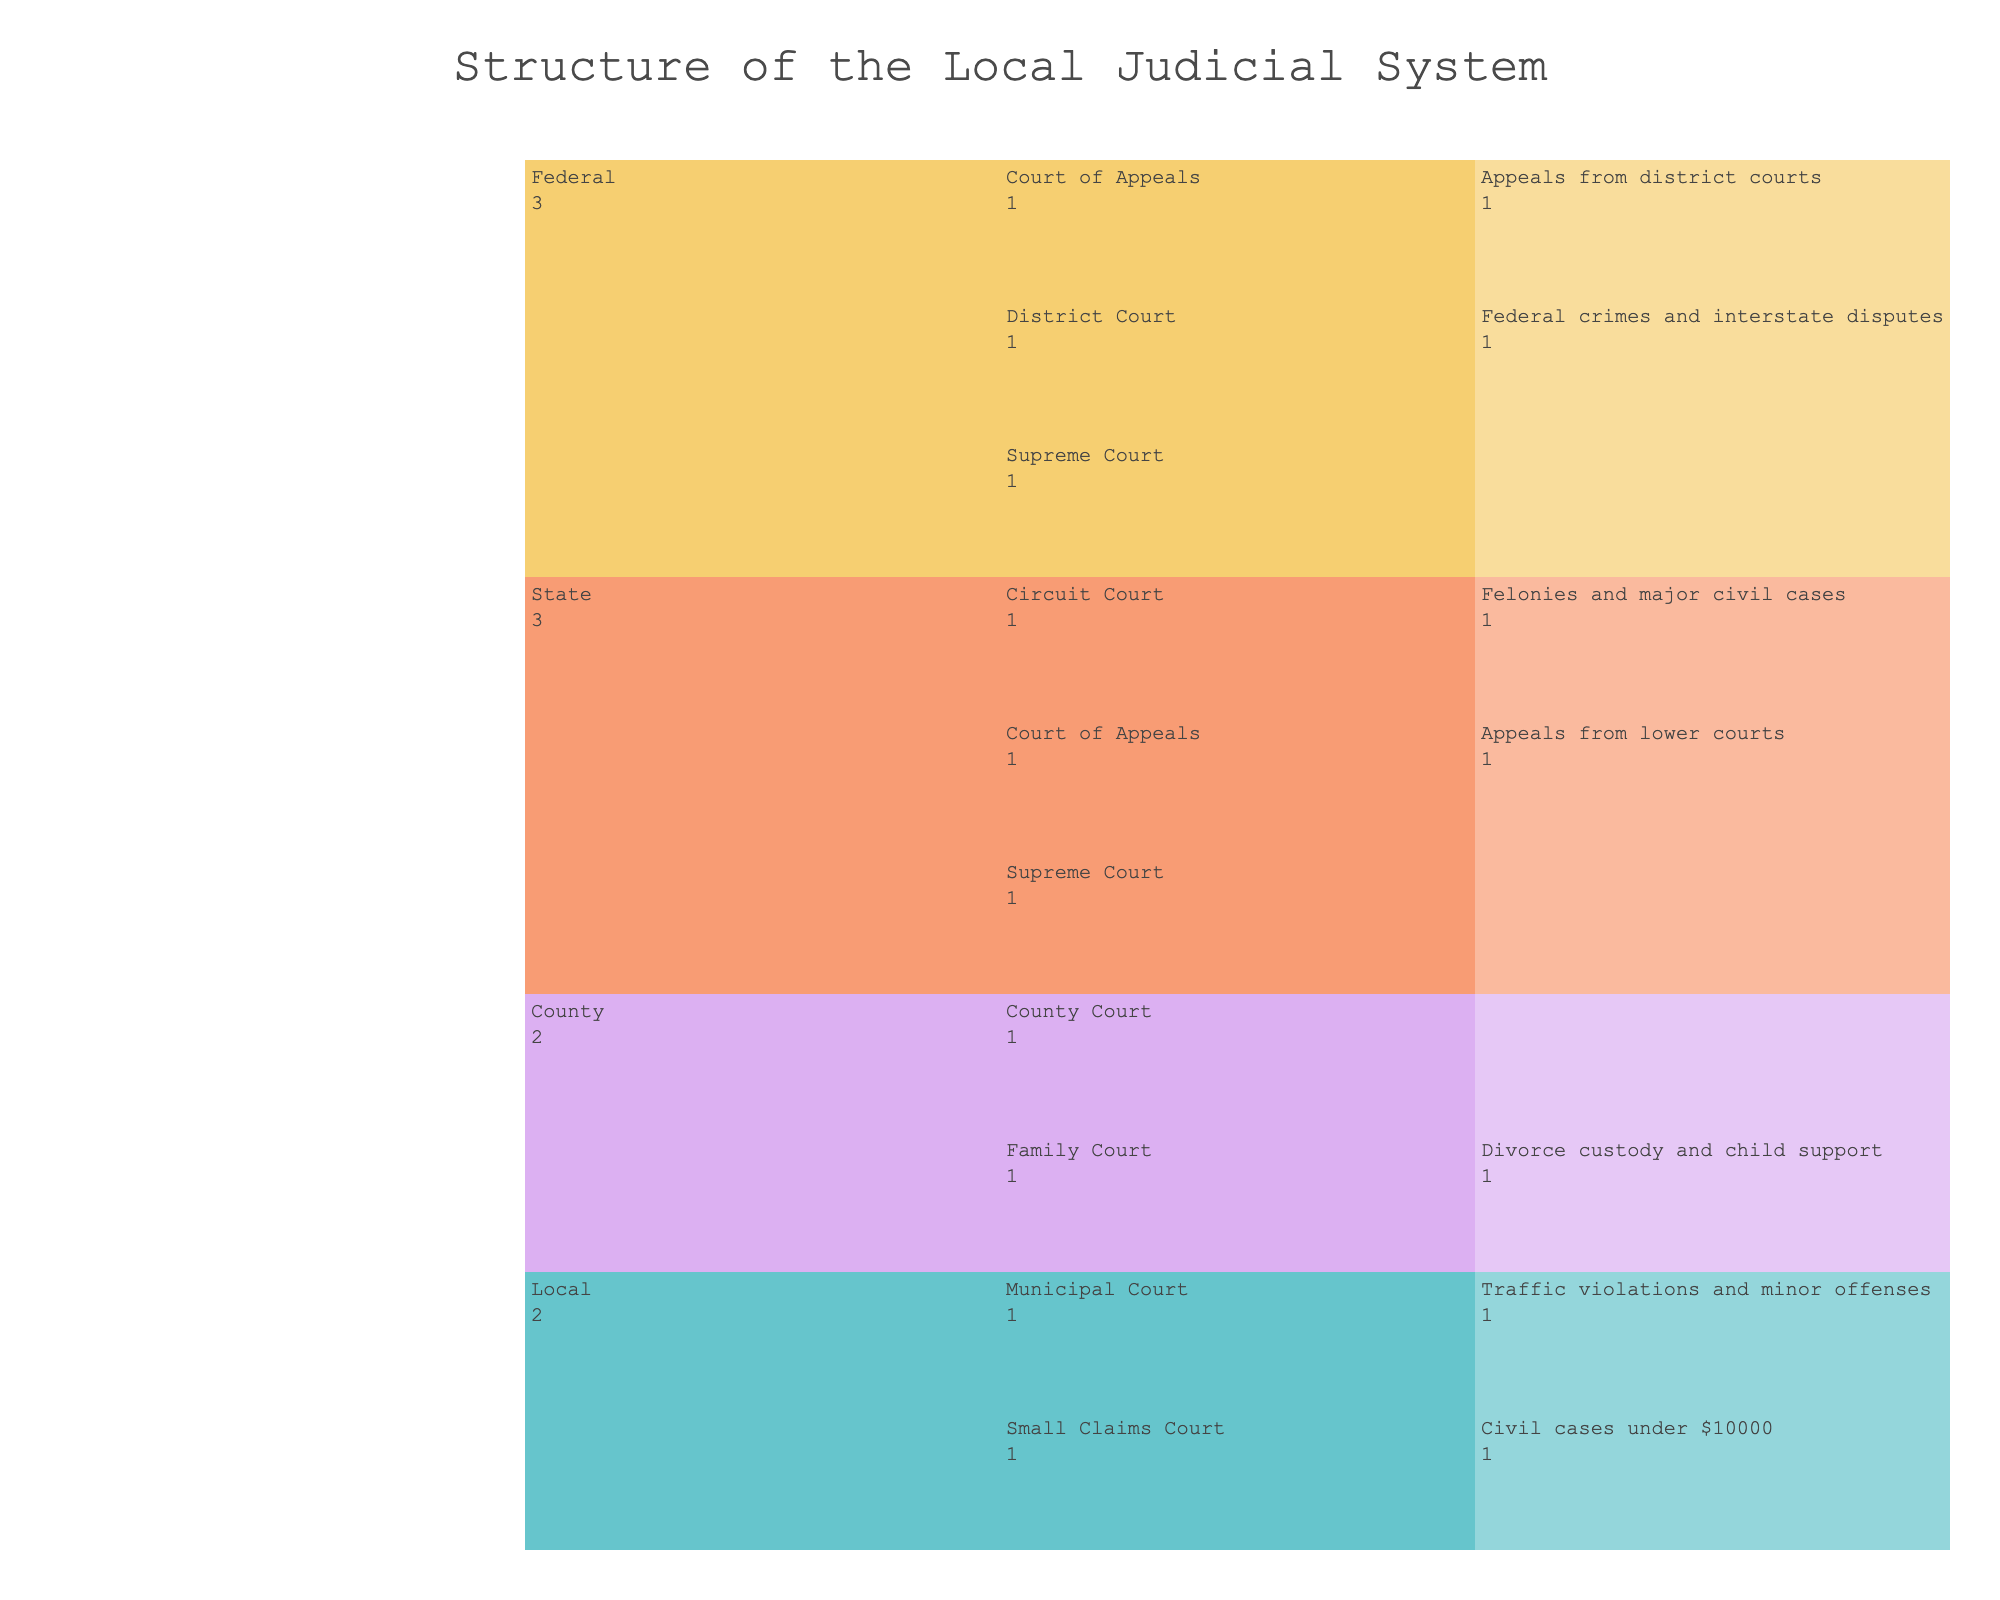What is the title of the icicle chart? The title is usually displayed at the top of the icicle chart. In this case, it is directly mentioned in the code itself.
Answer: Structure of the Local Judicial System Which court's jurisdiction includes traffic violations and minor offenses? To find the jurisdiction for traffic violations and minor offenses, locate the appropriate description under the 'Jurisdiction' column in the 'Municipal Court' section.
Answer: Municipal Court How many courts are listed under the 'State' level? To determine the number of courts listed under the 'State' level, count the unique courts that fall under the 'State' category in the icicle chart. There are three courts under 'State' level: Circuit Court, Court of Appeals, and Supreme Court.
Answer: 3 What type of cases does the Supreme Court at the Federal level handle? Look for the description under 'Jurisdiction' in the Federal level for the Supreme Court.
Answer: Constitutional issues and federal law interpretation Which level handles the most varied types of court cases based on the chart? To determine which level handles the most varied types of court cases, count the unique types of courts under each level. The Federal level has three courts listed — District Court, Court of Appeals, and Supreme Court, each handling different jurisdictions. This makes it the level with the most varied types of court cases.
Answer: Federal What is the main difference between the jurisdictions of the Circuit Court and the County Court? Compare the jurisdictions listed for Circuit Court and County Court by looking at the 'Jurisdiction' descriptions. The Circuit Court handles felonies and major civil cases, while the County Court handles misdemeanors and civil cases under $25000.
Answer: Circuit Court handles felonies and major civil cases, County Court handles misdemeanors and civil cases under $25000 Which court operates at both the County and State levels in terms of their functions (not limited to their names)? By analyzing the given information, no court is listed under both County and State in terms of its functions. This indicates that courts are specific to their jurisdiction level.
Answer: None What types of cases does the Family Court deal with? By checking the jurisdiction of Family Court, you will see it deals with divorce custody and child support.
Answer: Divorce custody and child support Which court handles appeals from lower courts at the State level? Locate the court under the State level that has 'appeals from lower courts' in its jurisdiction. It is the Court of Appeals.
Answer: Court of Appeals 